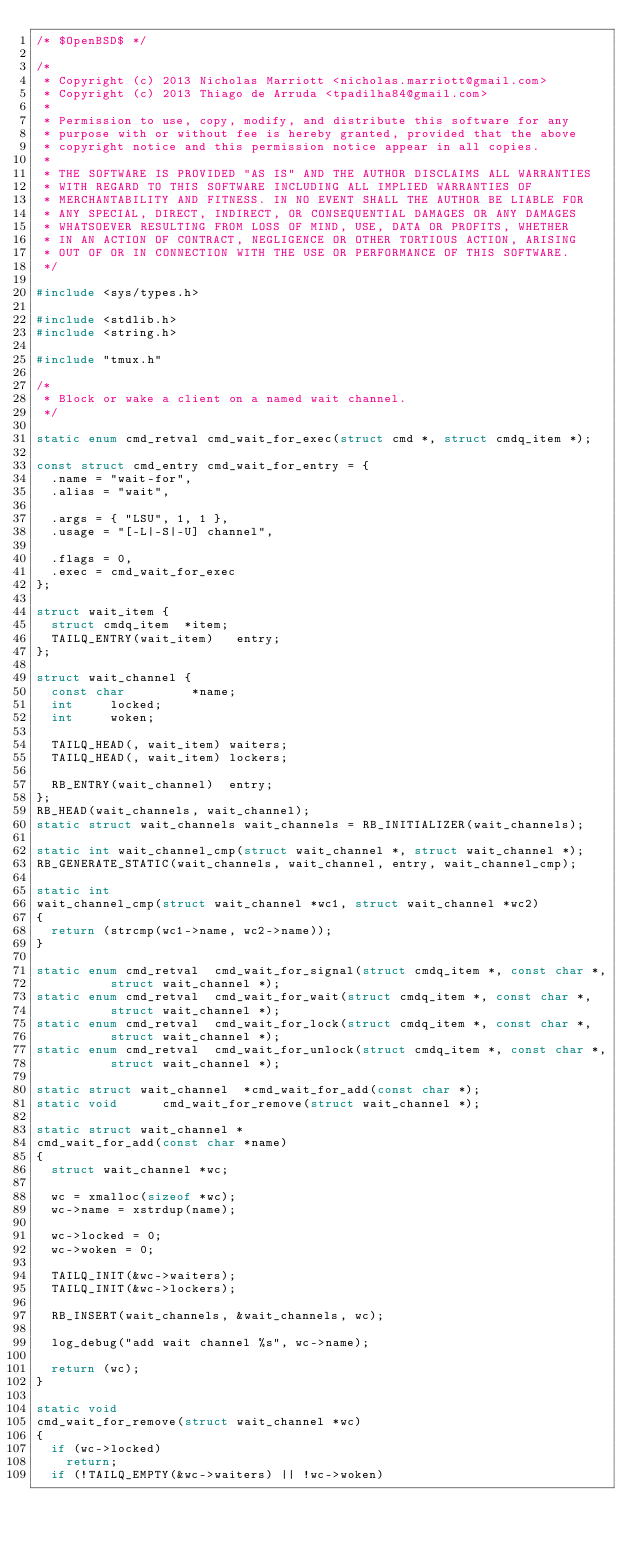Convert code to text. <code><loc_0><loc_0><loc_500><loc_500><_C_>/* $OpenBSD$ */

/*
 * Copyright (c) 2013 Nicholas Marriott <nicholas.marriott@gmail.com>
 * Copyright (c) 2013 Thiago de Arruda <tpadilha84@gmail.com>
 *
 * Permission to use, copy, modify, and distribute this software for any
 * purpose with or without fee is hereby granted, provided that the above
 * copyright notice and this permission notice appear in all copies.
 *
 * THE SOFTWARE IS PROVIDED "AS IS" AND THE AUTHOR DISCLAIMS ALL WARRANTIES
 * WITH REGARD TO THIS SOFTWARE INCLUDING ALL IMPLIED WARRANTIES OF
 * MERCHANTABILITY AND FITNESS. IN NO EVENT SHALL THE AUTHOR BE LIABLE FOR
 * ANY SPECIAL, DIRECT, INDIRECT, OR CONSEQUENTIAL DAMAGES OR ANY DAMAGES
 * WHATSOEVER RESULTING FROM LOSS OF MIND, USE, DATA OR PROFITS, WHETHER
 * IN AN ACTION OF CONTRACT, NEGLIGENCE OR OTHER TORTIOUS ACTION, ARISING
 * OUT OF OR IN CONNECTION WITH THE USE OR PERFORMANCE OF THIS SOFTWARE.
 */

#include <sys/types.h>

#include <stdlib.h>
#include <string.h>

#include "tmux.h"

/*
 * Block or wake a client on a named wait channel.
 */

static enum cmd_retval cmd_wait_for_exec(struct cmd *, struct cmdq_item *);

const struct cmd_entry cmd_wait_for_entry = {
	.name = "wait-for",
	.alias = "wait",

	.args = { "LSU", 1, 1 },
	.usage = "[-L|-S|-U] channel",

	.flags = 0,
	.exec = cmd_wait_for_exec
};

struct wait_item {
	struct cmdq_item	*item;
	TAILQ_ENTRY(wait_item)	 entry;
};

struct wait_channel {
	const char	       *name;
	int			locked;
	int			woken;

	TAILQ_HEAD(, wait_item)	waiters;
	TAILQ_HEAD(, wait_item)	lockers;

	RB_ENTRY(wait_channel)	entry;
};
RB_HEAD(wait_channels, wait_channel);
static struct wait_channels wait_channels = RB_INITIALIZER(wait_channels);

static int wait_channel_cmp(struct wait_channel *, struct wait_channel *);
RB_GENERATE_STATIC(wait_channels, wait_channel, entry, wait_channel_cmp);

static int
wait_channel_cmp(struct wait_channel *wc1, struct wait_channel *wc2)
{
	return (strcmp(wc1->name, wc2->name));
}

static enum cmd_retval	cmd_wait_for_signal(struct cmdq_item *, const char *,
			    struct wait_channel *);
static enum cmd_retval	cmd_wait_for_wait(struct cmdq_item *, const char *,
			    struct wait_channel *);
static enum cmd_retval	cmd_wait_for_lock(struct cmdq_item *, const char *,
			    struct wait_channel *);
static enum cmd_retval	cmd_wait_for_unlock(struct cmdq_item *, const char *,
			    struct wait_channel *);

static struct wait_channel	*cmd_wait_for_add(const char *);
static void			 cmd_wait_for_remove(struct wait_channel *);

static struct wait_channel *
cmd_wait_for_add(const char *name)
{
	struct wait_channel *wc;

	wc = xmalloc(sizeof *wc);
	wc->name = xstrdup(name);

	wc->locked = 0;
	wc->woken = 0;

	TAILQ_INIT(&wc->waiters);
	TAILQ_INIT(&wc->lockers);

	RB_INSERT(wait_channels, &wait_channels, wc);

	log_debug("add wait channel %s", wc->name);

	return (wc);
}

static void
cmd_wait_for_remove(struct wait_channel *wc)
{
	if (wc->locked)
		return;
	if (!TAILQ_EMPTY(&wc->waiters) || !wc->woken)</code> 